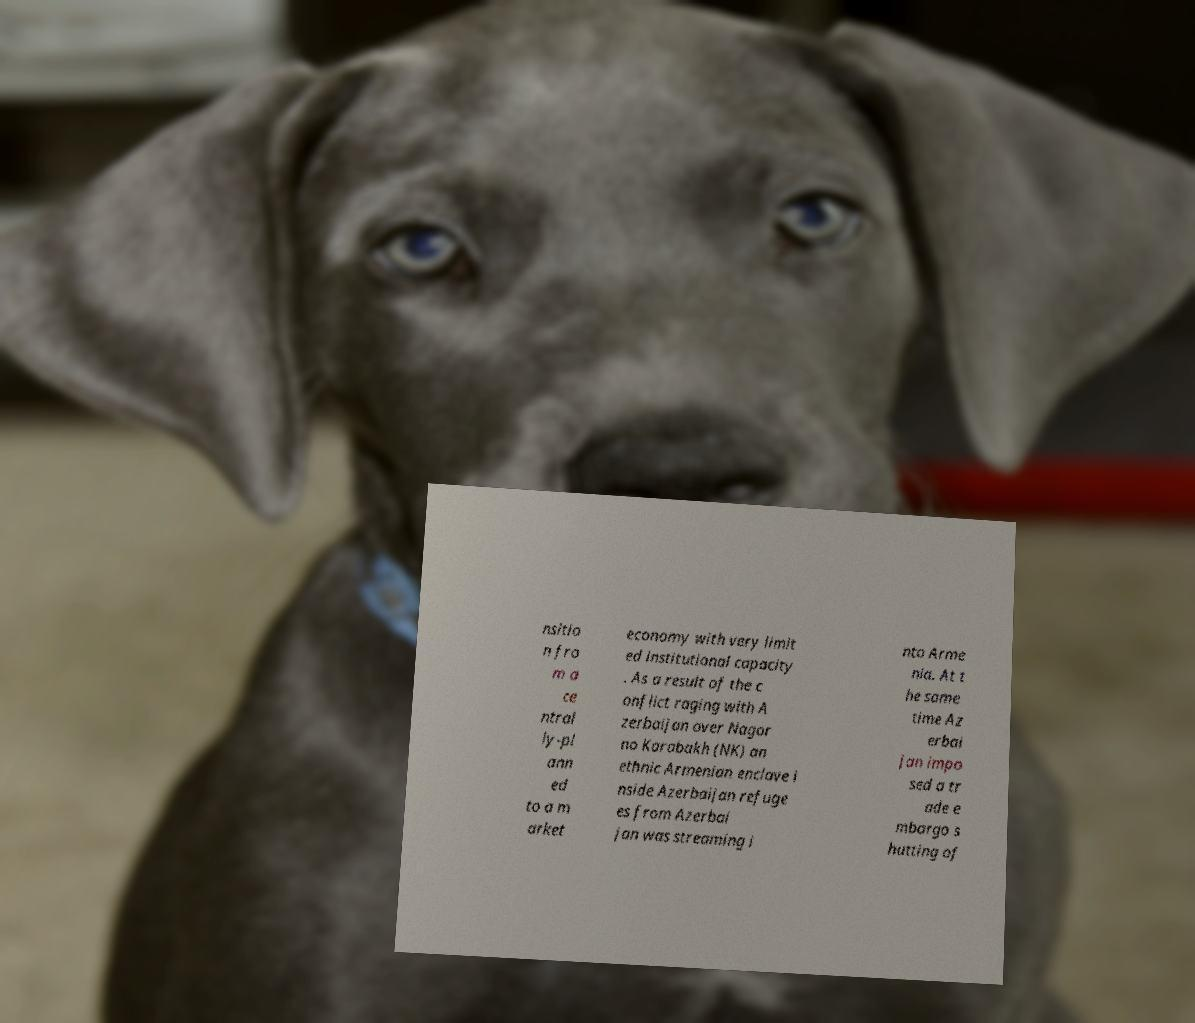There's text embedded in this image that I need extracted. Can you transcribe it verbatim? nsitio n fro m a ce ntral ly-pl ann ed to a m arket economy with very limit ed institutional capacity . As a result of the c onflict raging with A zerbaijan over Nagor no Karabakh (NK) an ethnic Armenian enclave i nside Azerbaijan refuge es from Azerbai jan was streaming i nto Arme nia. At t he same time Az erbai jan impo sed a tr ade e mbargo s hutting of 